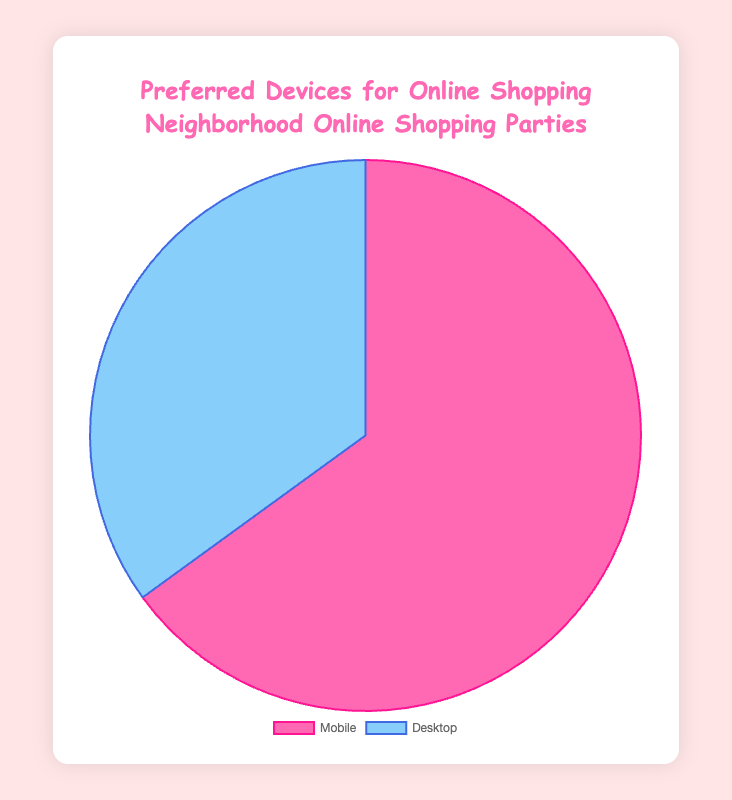What is the percentage of people who prefer using Mobile for online shopping? The pie chart shows two data points, and the percentage for Mobile is directly labeled as 65%.
Answer: 65% What is the percentage of people who use Desktop for online shopping compared to Mobile? Compare the percentages presented on the pie chart: Mobile is 65% and Desktop is 35%. Desktop's percentage is less than Mobile's.
Answer: Less By how much does the percentage of Mobile users exceed Desktop users? Subtract the percentage of Desktop users (35%) from the percentage of Mobile users (65%), which is 65% - 35%.
Answer: 30% If the total number of people surveyed is 200, how many prefer using Desktop for online shopping? Calculate 35% of 200 by multiplying 200 by 0.35, which is 200 * 0.35.
Answer: 70 What is the combined percentage of Mobile and Desktop users? Add the percentages of both data points: Mobile (65%) + Desktop (35%).
Answer: 100% Which device is more popular for online shopping based on the chart? The chart shows that Mobile has a higher percentage (65%) than Desktop (35%), indicating Mobile is more popular.
Answer: Mobile If 50 more people start using Mobile, bringing the total to 250, what will be the new percentage of Mobile users? Divide the new number of Mobile users (50 additional people to existing 65% of 200, so 180) by the new total number of users (200 + 50), then multiply by 100. Calculation: (180 / 250) * 100.
Answer: 72% What are the colors used to represent Mobile and Desktop in the pie chart? Visually identify the colors from the pie chart: Mobile is represented by pink, and Desktop by light blue.
Answer: Pink and Light Blue What does the legend position indicate about the pie chart's layout? The legend is positioned at the bottom of the chart, which means it is displayed below the pie chart for better readability and reference.
Answer: Bottom Which device preference has a darker border color on the pie chart? Identify the border color differences visually: Mobile has a hot pink border, and Desktop has a dark blue border. The hot pink border appears visually darker than the dark blue.
Answer: Mobile 